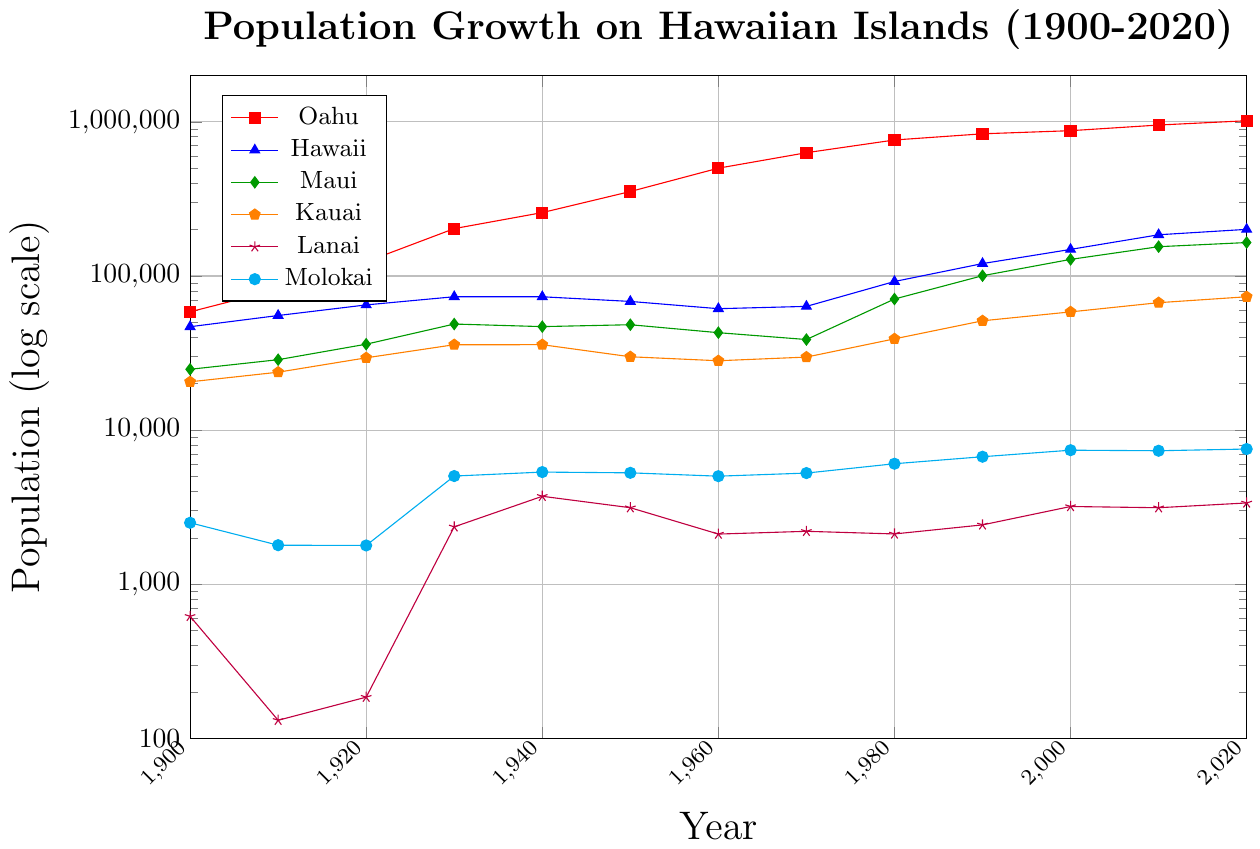Which island had the largest population in 2020? The chart shows the population for each island in 2020. By looking at the endpoints of all the lines, we can see that Oahu's population is the highest.
Answer: Oahu Which island's population showed the most dramatic increase between 1900 and 1920? By comparing the slope of each line segment from 1900 to 1920, we can see that Oahu's population increase was the steepest on a log scale, indicating the most dramatic growth.
Answer: Oahu Between which decades did Hawaii's population see the largest increase? By tracing Hawaii's line and calculating the difference between populations at each decade, the biggest jump occurs between 1970 and 1980, going from about 63,468 to 92,053, a significant increase.
Answer: 1970-1980 What was the approximate population of Lanai in 1930? Locate the point on Lanai's line corresponding to 1930. The value is just above the 1,000 mark, estimated around 2,356.
Answer: 2,356 How does Maui's population in 2020 compare visually to Oahu's population in 2000? Find Maui's population in 2020 and Oahu's population in 2000. Maui in 2020 (164,754) is approximately the same as Oahu in 2000 (876,156) when comparing on the log scale, indicating Maui's is much less.
Answer: Much less Which island had the smallest population in 1900, and how significant is the difference compared to the next smallest island? In 1900, Lanai had the smallest population at 619. The next smallest was Molokai at 2,504. The difference is significant, more than 4 times larger.
Answer: Lanai, significant Between 1900 and 2000, rank the islands in terms of population growth rate from highest to lowest. Look at the overall slope of the lines from 1900 to 2000. Oahu has the steepest overall slope indicating the highest growth rate, then Hawaii, followed by Kauai, Maui, Molokai, and Lanai.
Answer: Oahu > Hawaii > Kauai > Maui > Molokai > Lanai What year saw a significant spike in Molokai's population and what might that number be? The chart shows a noticeable spike in Molokai's population around 1930. By checking the value, it reaches around 5032 in that year.
Answer: 1930, 5032 